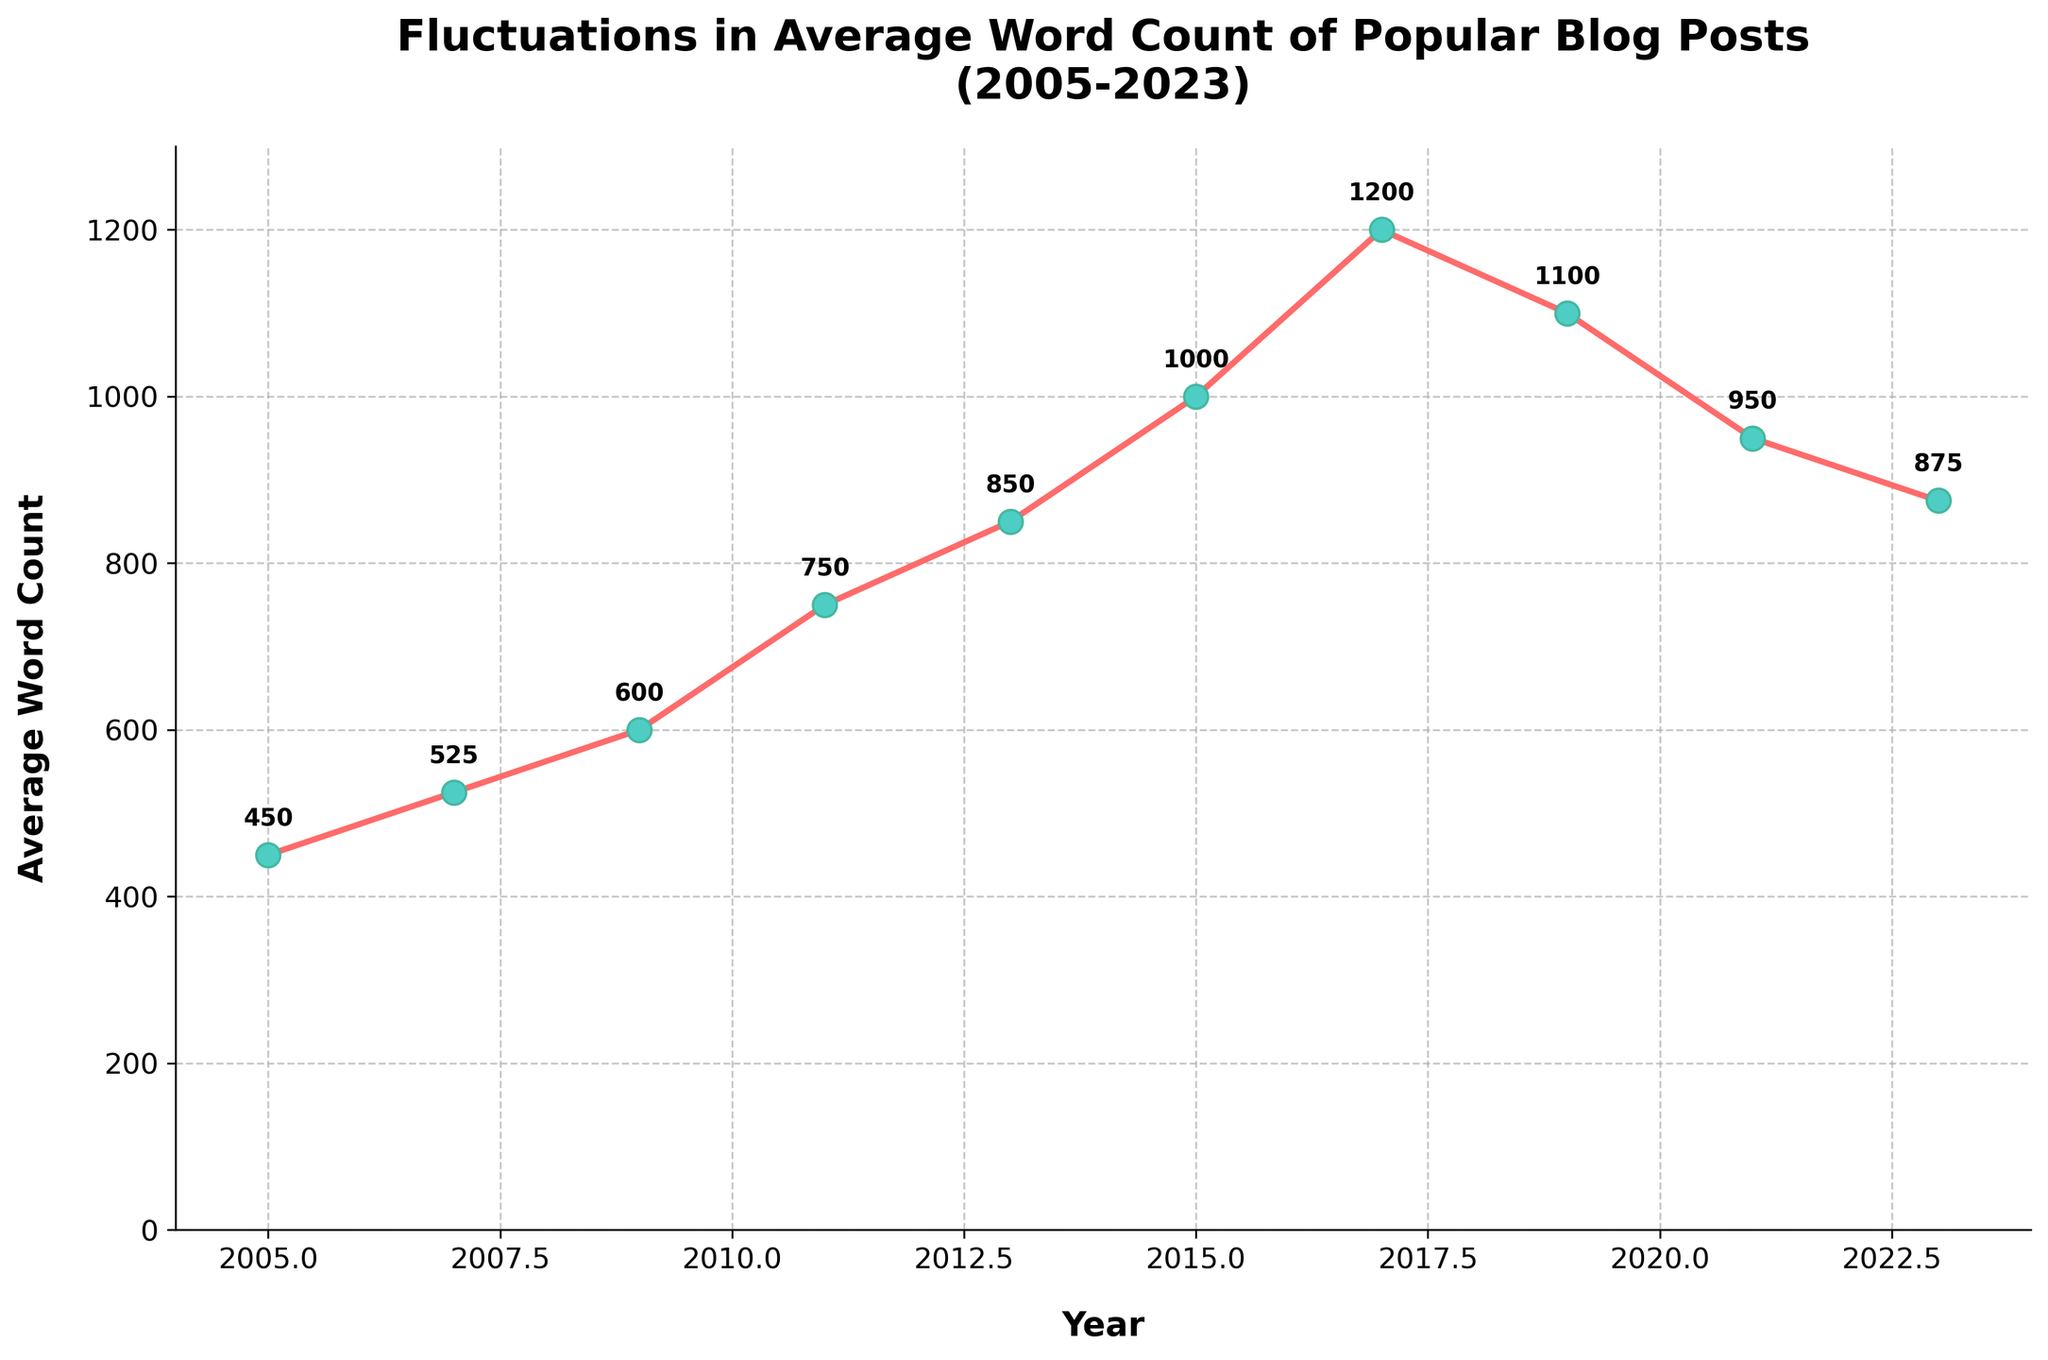What's the highest average word count observed in the figure? The highest point on the line chart is at 2017, where the average word count is 1200.
Answer: 1200 Which years showed a decrease in average word count compared to the previous recorded year? By examining the chart, the average word count decreased between 2017 and 2019, 2019 and 2021, and 2021 and 2023.
Answer: 2017–2019, 2019–2021, 2021–2023 During which period did the average word count increase the most? From 2005 to 2017, observe that the largest jump occurs between 2015 and 2017, with an increase from 1000 to 1200 words, which is an increase of 200 words.
Answer: 2015–2017 By how much did the average word count drop from its peak to the latest recorded year? The average word count peaked at 1200 in 2017 and dropped to 875 in 2023. The difference is 1200 - 875 = 325.
Answer: 325 What is the average word count for the years 2015, 2017, and 2019 combined? Add the word counts for 2015, 2017, and 2019: (1000 + 1200 + 1100) = 3300. Divide by 3 to get the average: 3300 / 3 = 1100.
Answer: 1100 In which year did the average word count first exceed 500? The average word count exceeded 500 for the first time in 2009 based on the data shown in the figure.
Answer: 2009 Compare the average word count in 2005 and 2023. Which year had a higher count and by how much? In 2005, the average word count was 450. In 2023, it was 875. The difference is 875 - 450 = 425.
Answer: 2023 by 425 What is the total cumulative average word count from 2005 to 2023? Sum the average word counts for all years from the data: 450 + 525 + 600 + 750 + 850 + 1000 + 1200 + 1100 + 950 + 875 = 8300.
Answer: 8300 